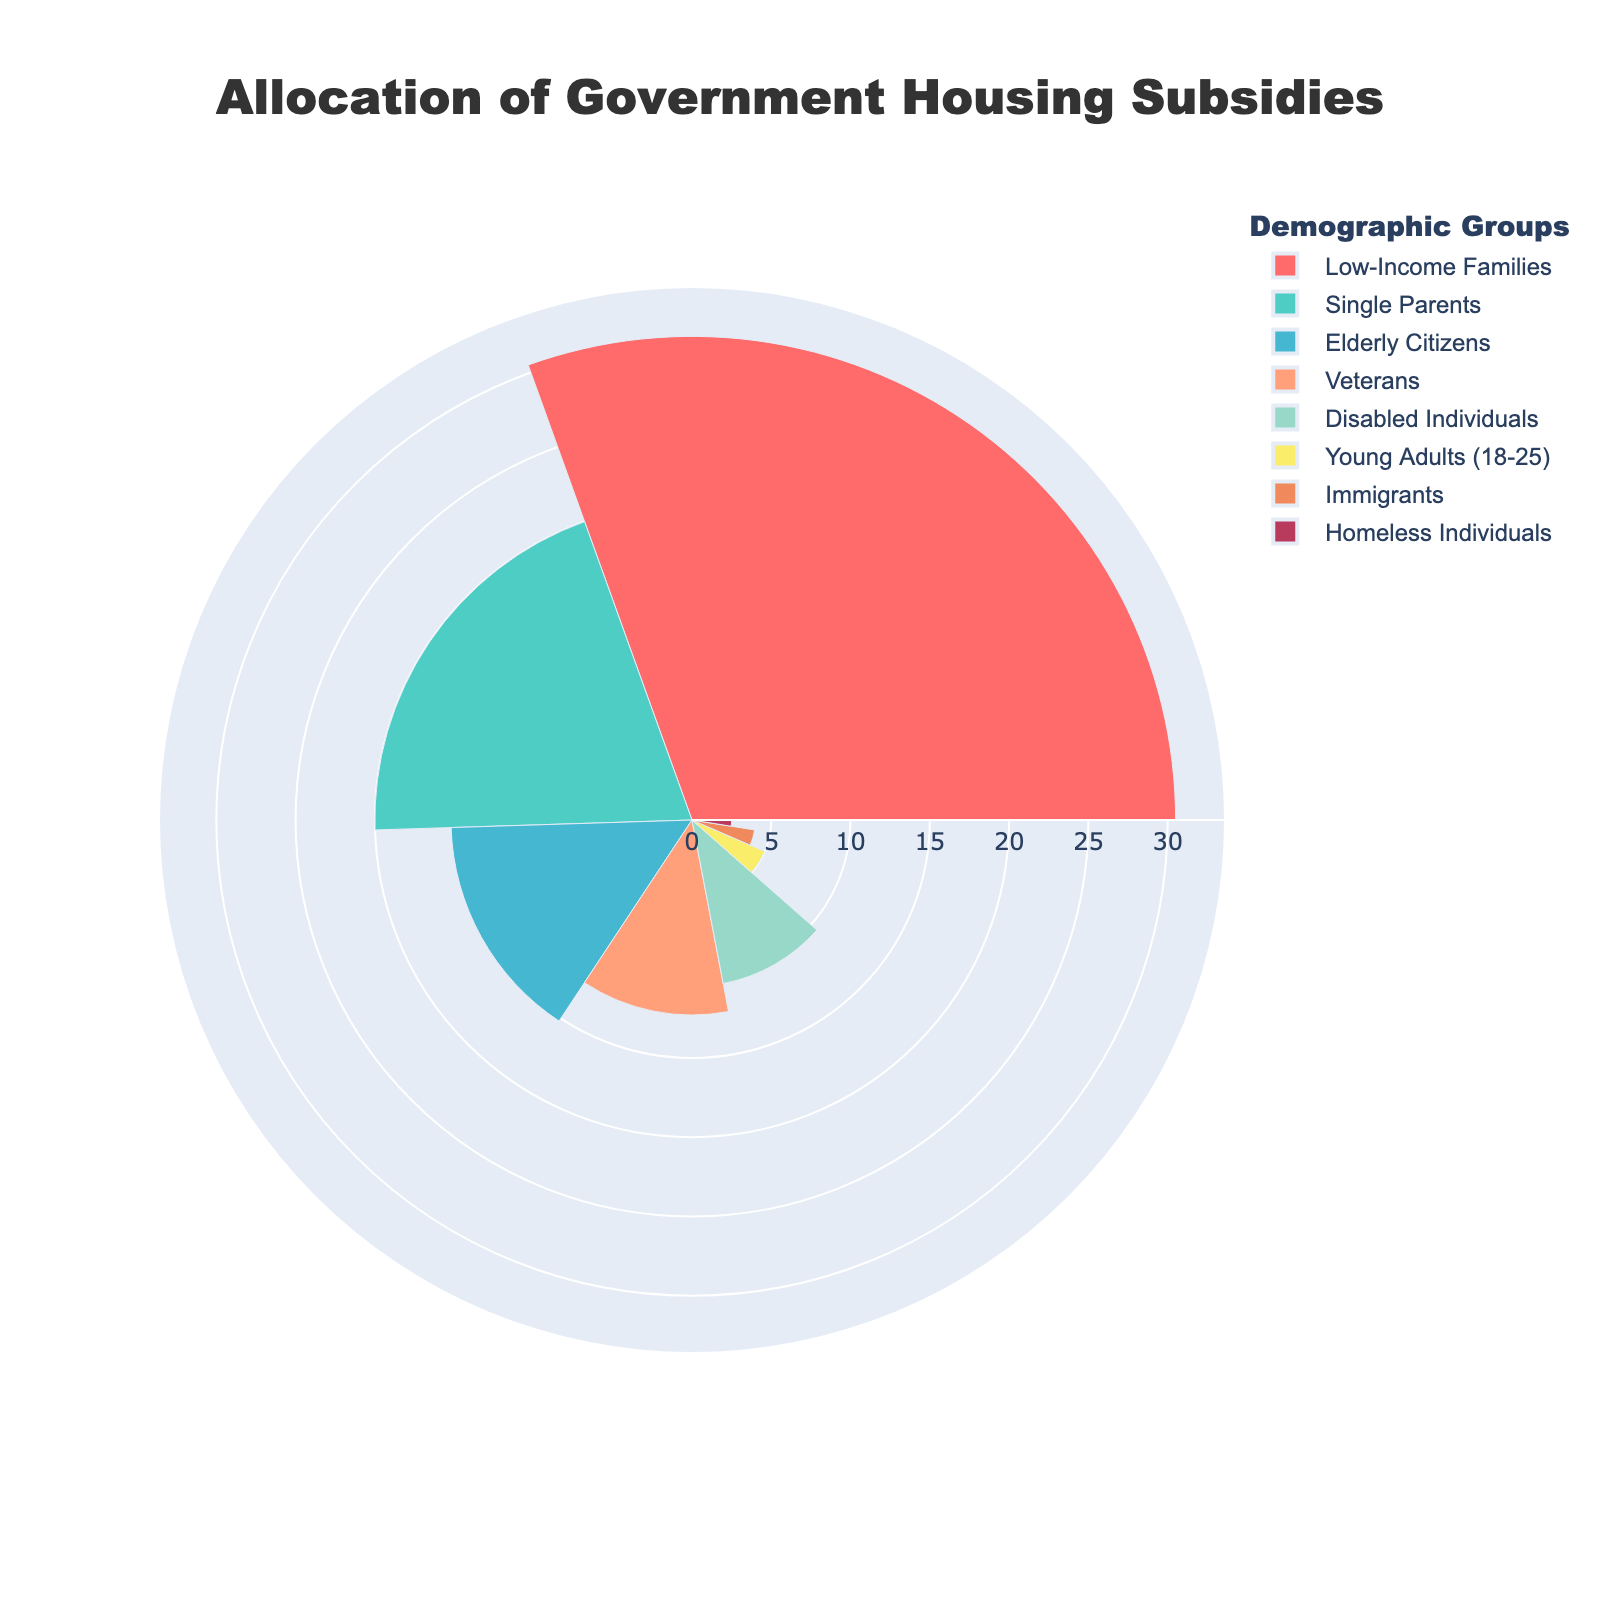Which demographic group receives the highest percentage of subsidies? By looking at the rose chart, we identify the demographic group with the largest slice. According to the figure, "Low-Income Families" have the largest portion of the chart.
Answer: Low-Income Families What percentage of subsidies is allocated to Single Parents and Elderly Citizens combined? From the chart, Single Parents receive 20.0% and Elderly Citizens receive 15.2%. Summing these percentages gives 20.0% + 15.2% = 35.2%.
Answer: 35.2% How much more subsidy percentage is allocated to Veterans compared to Immigrants? By examining the chart, we see Veterans receive 12.3%, and Immigrants receive 4.0%. The difference is 12.3% - 4.0% = 8.3%.
Answer: 8.3% Which demographic groups receive less than 10% of the subsidies? Upon reviewing the chart, we see that Young Adults (5.0%), Immigrants (4.0%), and Homeless Individuals (2.5%) each receive less than 10% of the subsidies.
Answer: Young Adults, Immigrants, Homeless Individuals How does the allocation to Disabled Individuals compare to that of Single Parents? From the chart, Disabled Individuals receive 10.5%, and Single Parents receive 20.0%. Thus, Single Parents receive a higher percentage than Disabled Individuals.
Answer: Single Parents receive more than Disabled Individuals What is the total percentage of subsidies allocated to Homeless Individuals and Young Adults? The chart shows Homeless Individuals receive 2.5% and Young Adults receive 5.0%. Adding these together, 2.5% + 5.0% = 7.5%.
Answer: 7.5% What's the difference in subsidy allocation between the largest and smallest demographic groups? The largest group, Low-Income Families, receives 30.5%, and the smallest group, Homeless Individuals, receives 2.5%. The difference is 30.5% - 2.5% = 28.0%.
Answer: 28.0% What is the average percentage of subsidies allocated to Veterans, Disabled Individuals, and Young Adults? Adding the percentages for Veterans (12.3%), Disabled Individuals (10.5%), and Young Adults (5.0%) gives a total of 12.3% + 10.5% + 5.0% = 27.8%. Dividing by 3 gives 27.8% / 3 = 9.27%.
Answer: 9.27% Which demographic group has a subsidy allocation closest to 10%? By inspecting the chart, Disabled Individuals receive 10.5%, which is closest to 10%.
Answer: Disabled Individuals Is the percentage of subsidies allocated to Single Parents more than double that of Immigrants? The chart shows Single Parents receive 20.0% and Immigrants receive 4.0%. Doubling the Immigrants' percentage gives 4.0% * 2 = 8.0%. Since 20.0% > 8.0%, the allocation to Single Parents is indeed more than double that of Immigrants.
Answer: Yes, more than double 